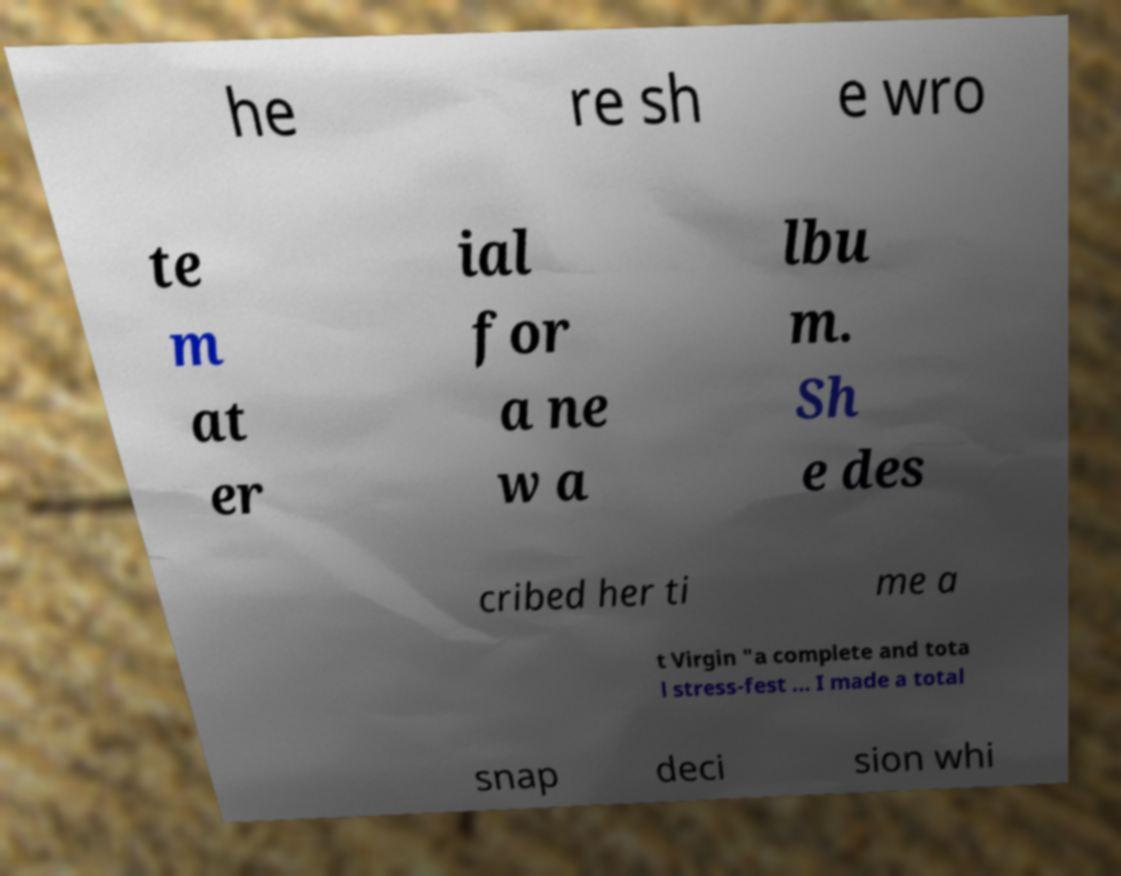I need the written content from this picture converted into text. Can you do that? he re sh e wro te m at er ial for a ne w a lbu m. Sh e des cribed her ti me a t Virgin "a complete and tota l stress-fest ... I made a total snap deci sion whi 